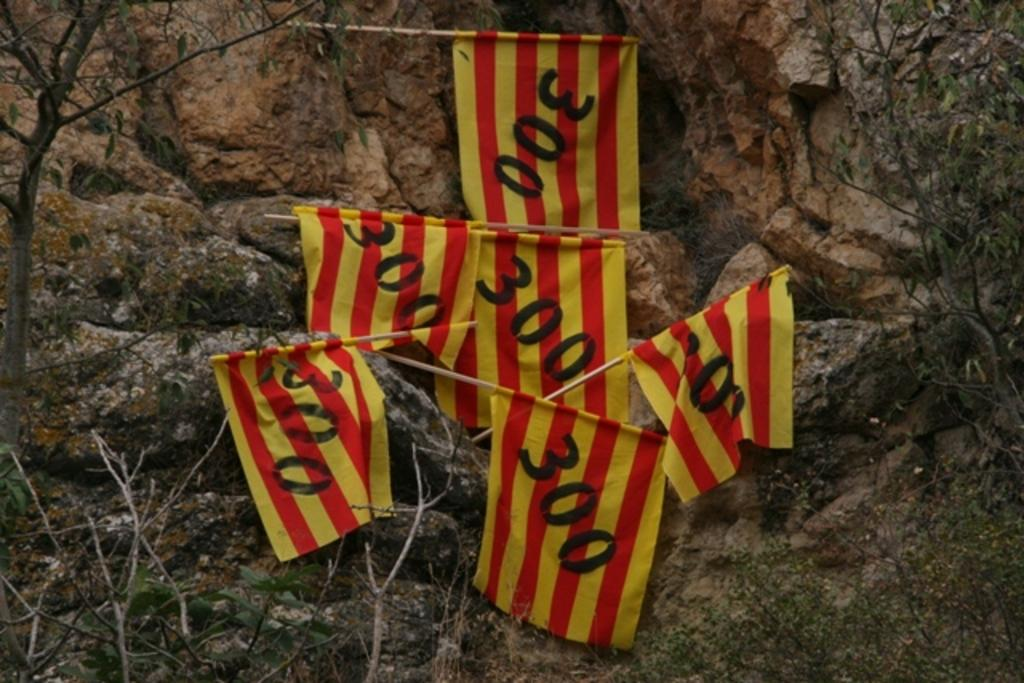What is on the rock in the image? There are flags on the rock in the image. What can be seen on the left side of the image? There are branches on the left side of the image. What can be seen on the right side of the image? There are branches on the right side of the image. What type of amusement is present in the image? There is no amusement present in the image; it features flags on a rock and branches on both sides. How does the agreement between the branches and the rock affect the image? There is no agreement between the branches and the rock, as they are separate elements in the image. 